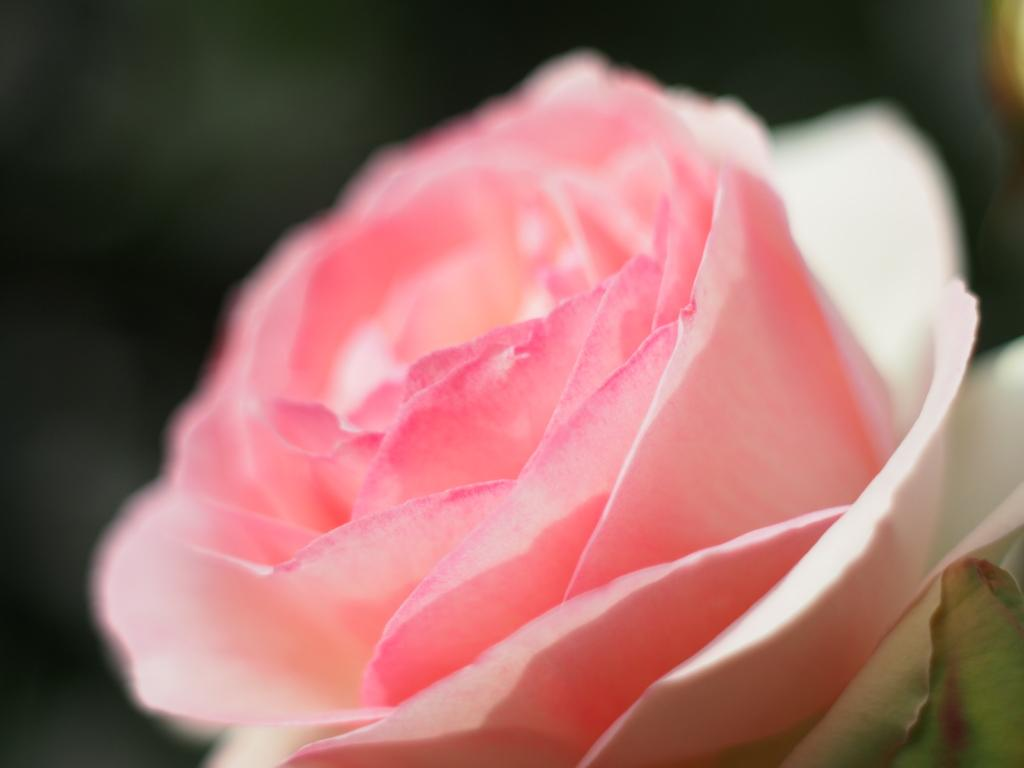What type of flower is in the picture? There is a rose flower in the picture. What color is the rose flower? The rose flower is pink in color. What type of linen is being used by the grandmother in the image? There is no grandmother or linen present in the image; it only features a pink rose flower. 